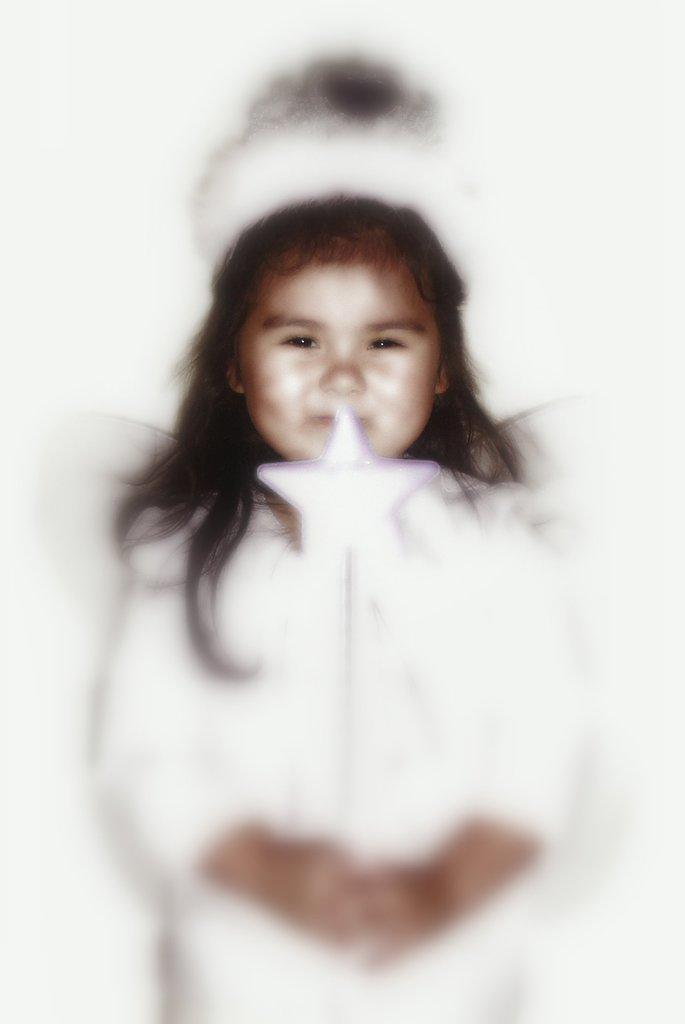What is the main subject of the image? The main subject of the image is a girl. What is the girl doing in the image? The girl is smiling in the image. What object is the girl holding in her hand? The girl is holding a star in her hand. What type of shade is the girl using to protect herself from the sun in the image? There is no shade present in the image, and the girl is not shown using any type of shade. What type of destruction is the girl causing in the image? There is no destruction present in the image, and the girl is not shown causing any type of destruction. Who is the manager of the girl in the image? There is no reference to a manager in the image, and the girl is not shown with any type of manager. 